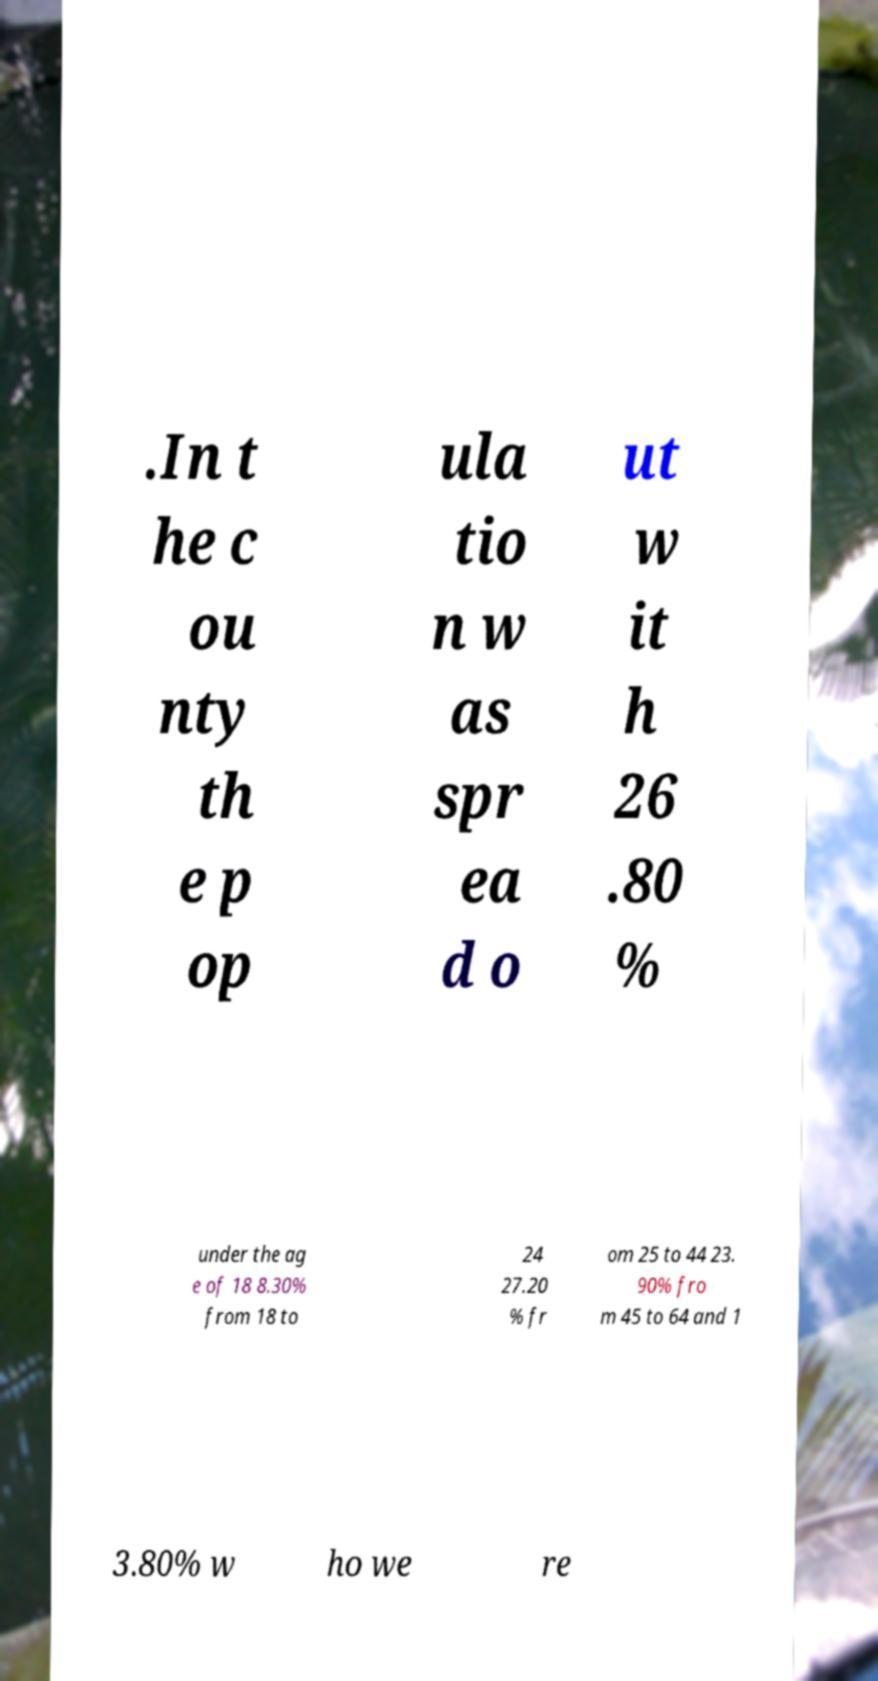Can you accurately transcribe the text from the provided image for me? .In t he c ou nty th e p op ula tio n w as spr ea d o ut w it h 26 .80 % under the ag e of 18 8.30% from 18 to 24 27.20 % fr om 25 to 44 23. 90% fro m 45 to 64 and 1 3.80% w ho we re 